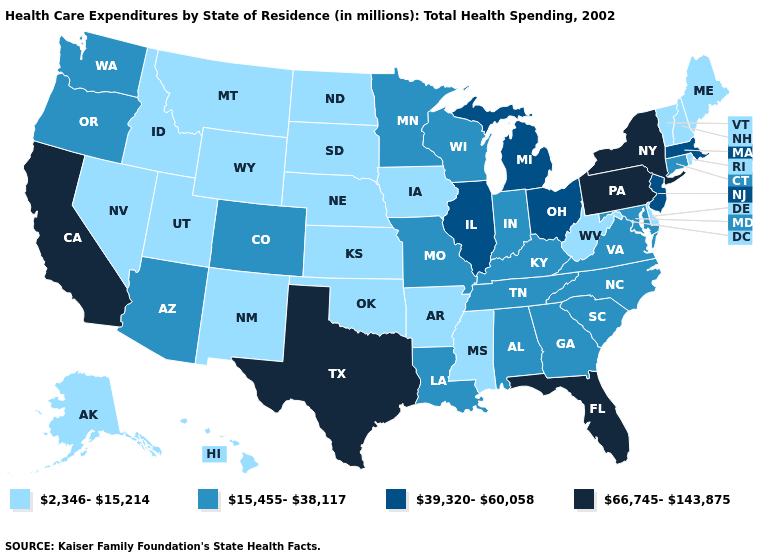Name the states that have a value in the range 39,320-60,058?
Answer briefly. Illinois, Massachusetts, Michigan, New Jersey, Ohio. What is the highest value in the MidWest ?
Quick response, please. 39,320-60,058. Name the states that have a value in the range 15,455-38,117?
Quick response, please. Alabama, Arizona, Colorado, Connecticut, Georgia, Indiana, Kentucky, Louisiana, Maryland, Minnesota, Missouri, North Carolina, Oregon, South Carolina, Tennessee, Virginia, Washington, Wisconsin. Among the states that border Virginia , does West Virginia have the lowest value?
Write a very short answer. Yes. How many symbols are there in the legend?
Short answer required. 4. What is the highest value in states that border Minnesota?
Answer briefly. 15,455-38,117. What is the value of Texas?
Be succinct. 66,745-143,875. What is the value of Kansas?
Quick response, please. 2,346-15,214. Name the states that have a value in the range 39,320-60,058?
Answer briefly. Illinois, Massachusetts, Michigan, New Jersey, Ohio. Name the states that have a value in the range 2,346-15,214?
Concise answer only. Alaska, Arkansas, Delaware, Hawaii, Idaho, Iowa, Kansas, Maine, Mississippi, Montana, Nebraska, Nevada, New Hampshire, New Mexico, North Dakota, Oklahoma, Rhode Island, South Dakota, Utah, Vermont, West Virginia, Wyoming. What is the value of South Carolina?
Short answer required. 15,455-38,117. Does the first symbol in the legend represent the smallest category?
Short answer required. Yes. Name the states that have a value in the range 66,745-143,875?
Be succinct. California, Florida, New York, Pennsylvania, Texas. Which states have the lowest value in the South?
Keep it brief. Arkansas, Delaware, Mississippi, Oklahoma, West Virginia. Does the first symbol in the legend represent the smallest category?
Give a very brief answer. Yes. 